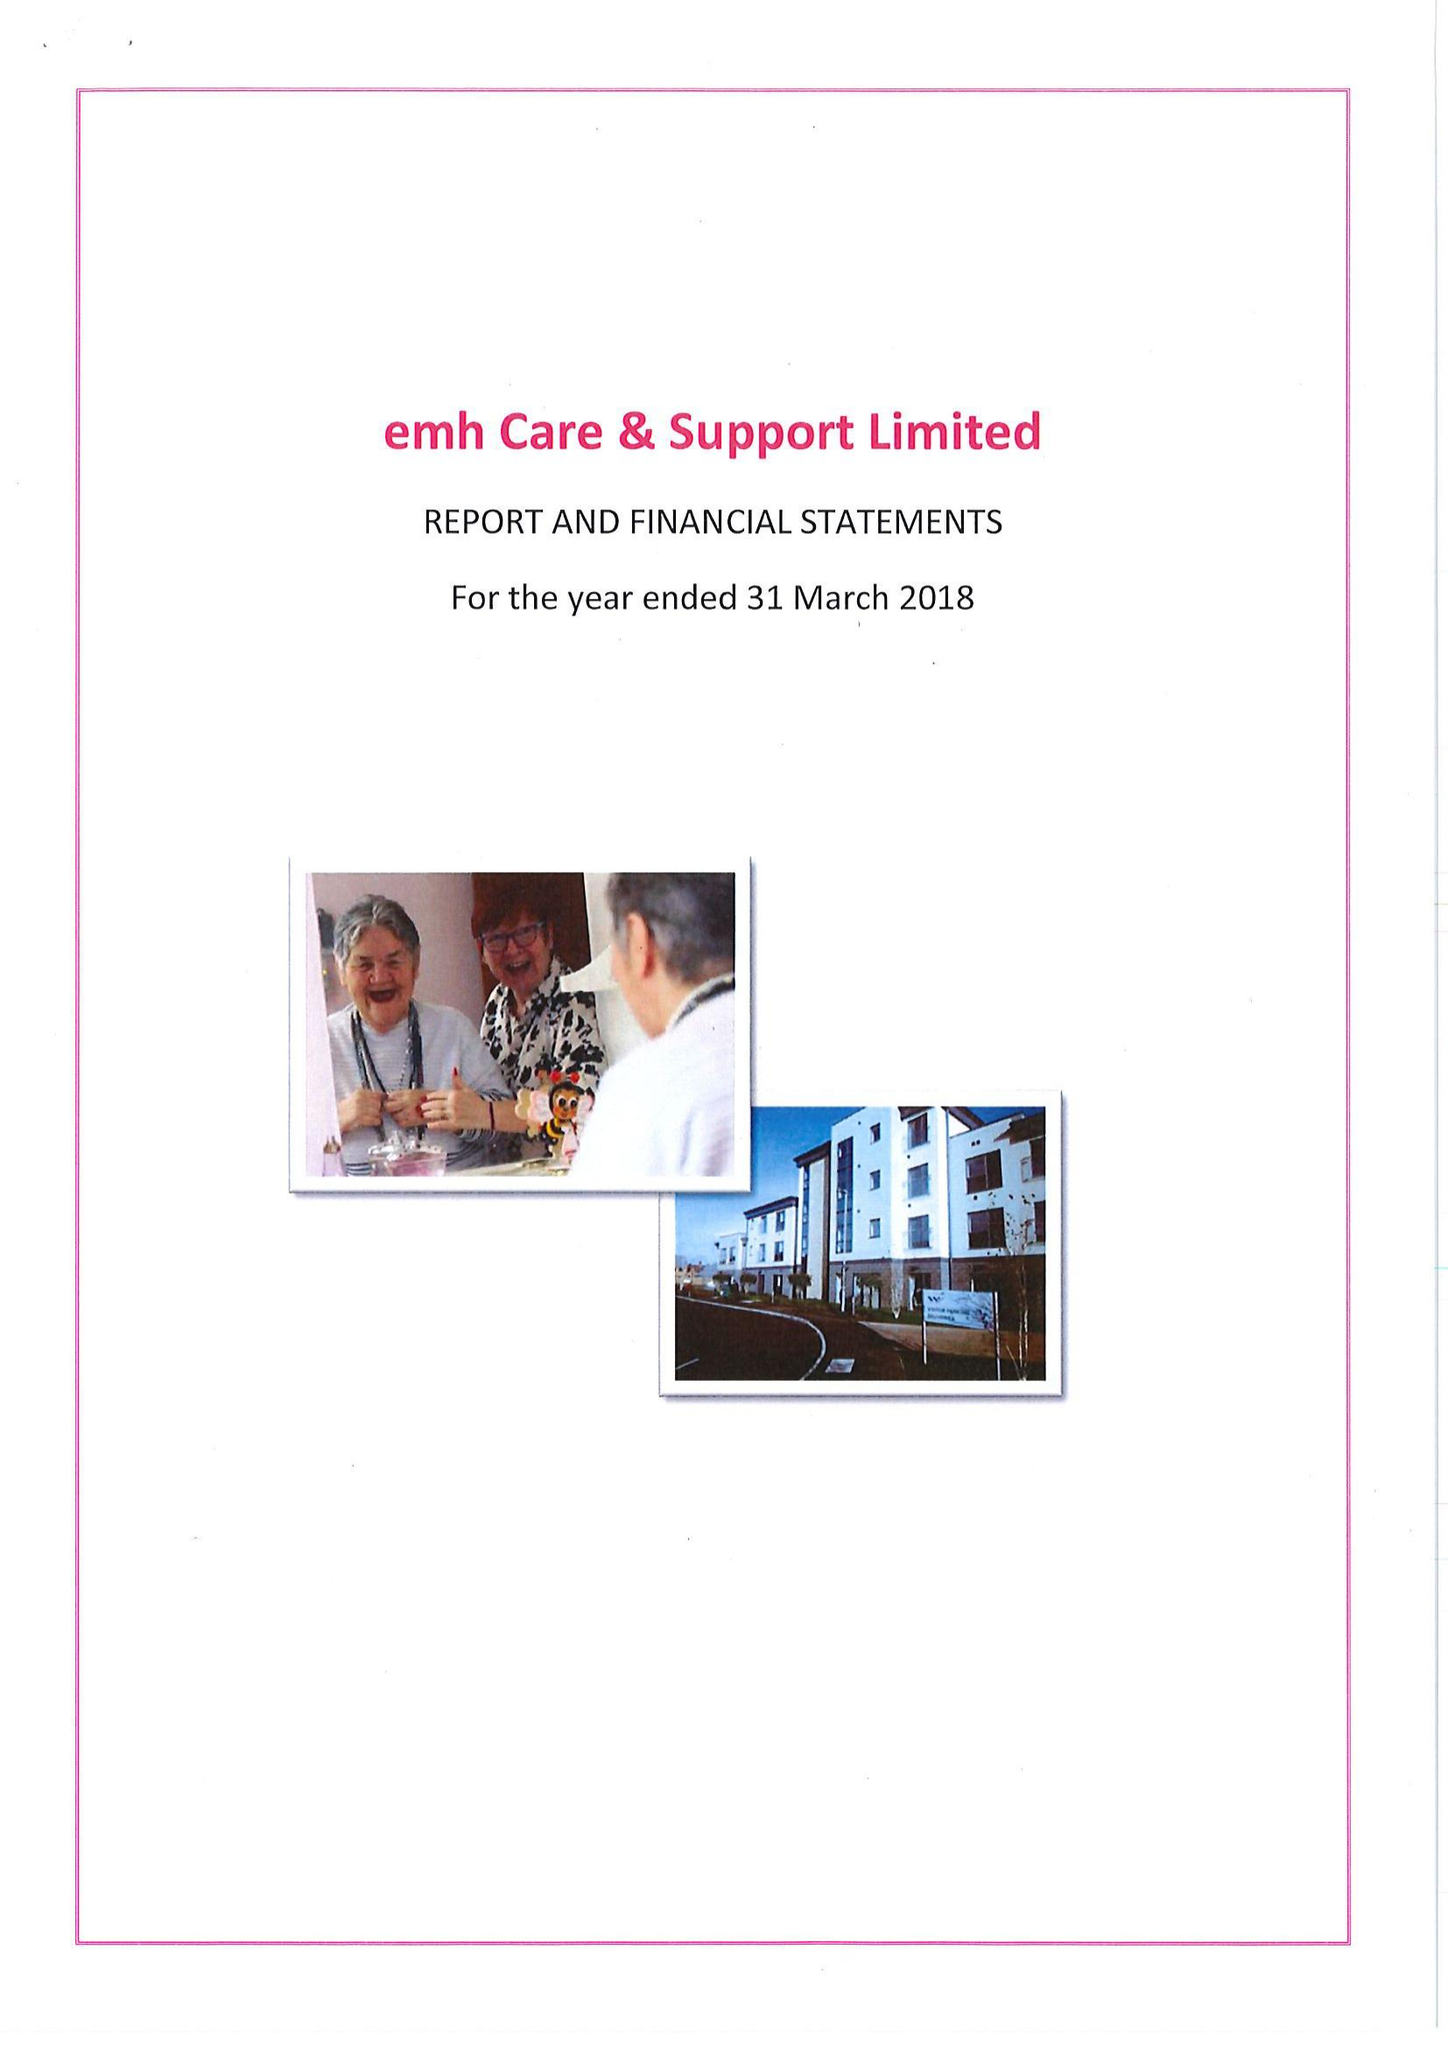What is the value for the report_date?
Answer the question using a single word or phrase. 2018-03-31 